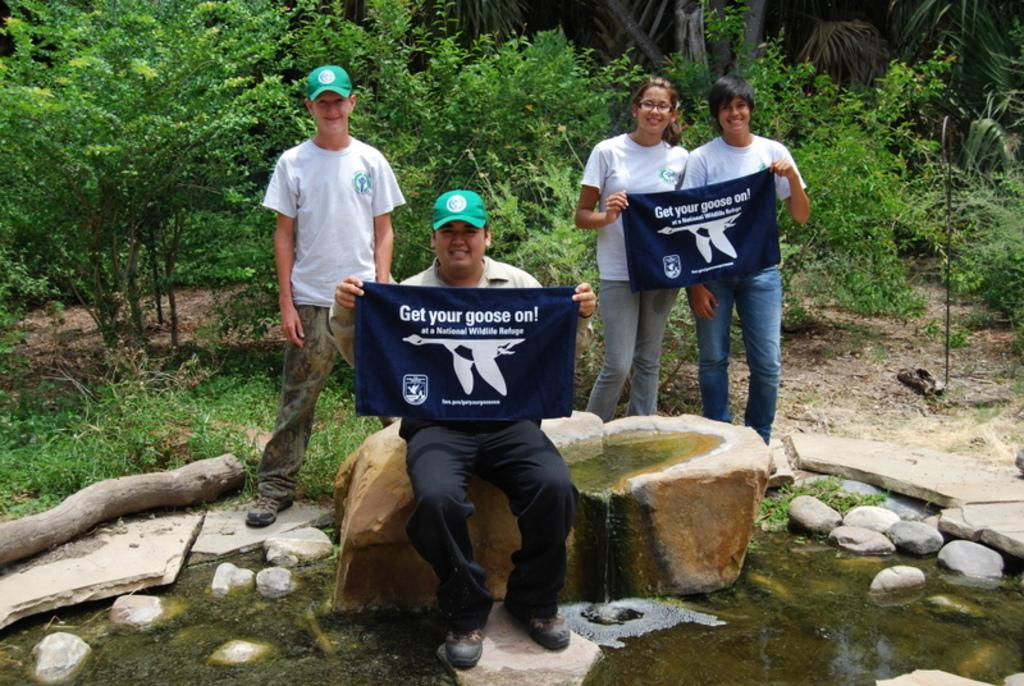<image>
Describe the image concisely. Group of people holding a sign that says "Get your goose on". 